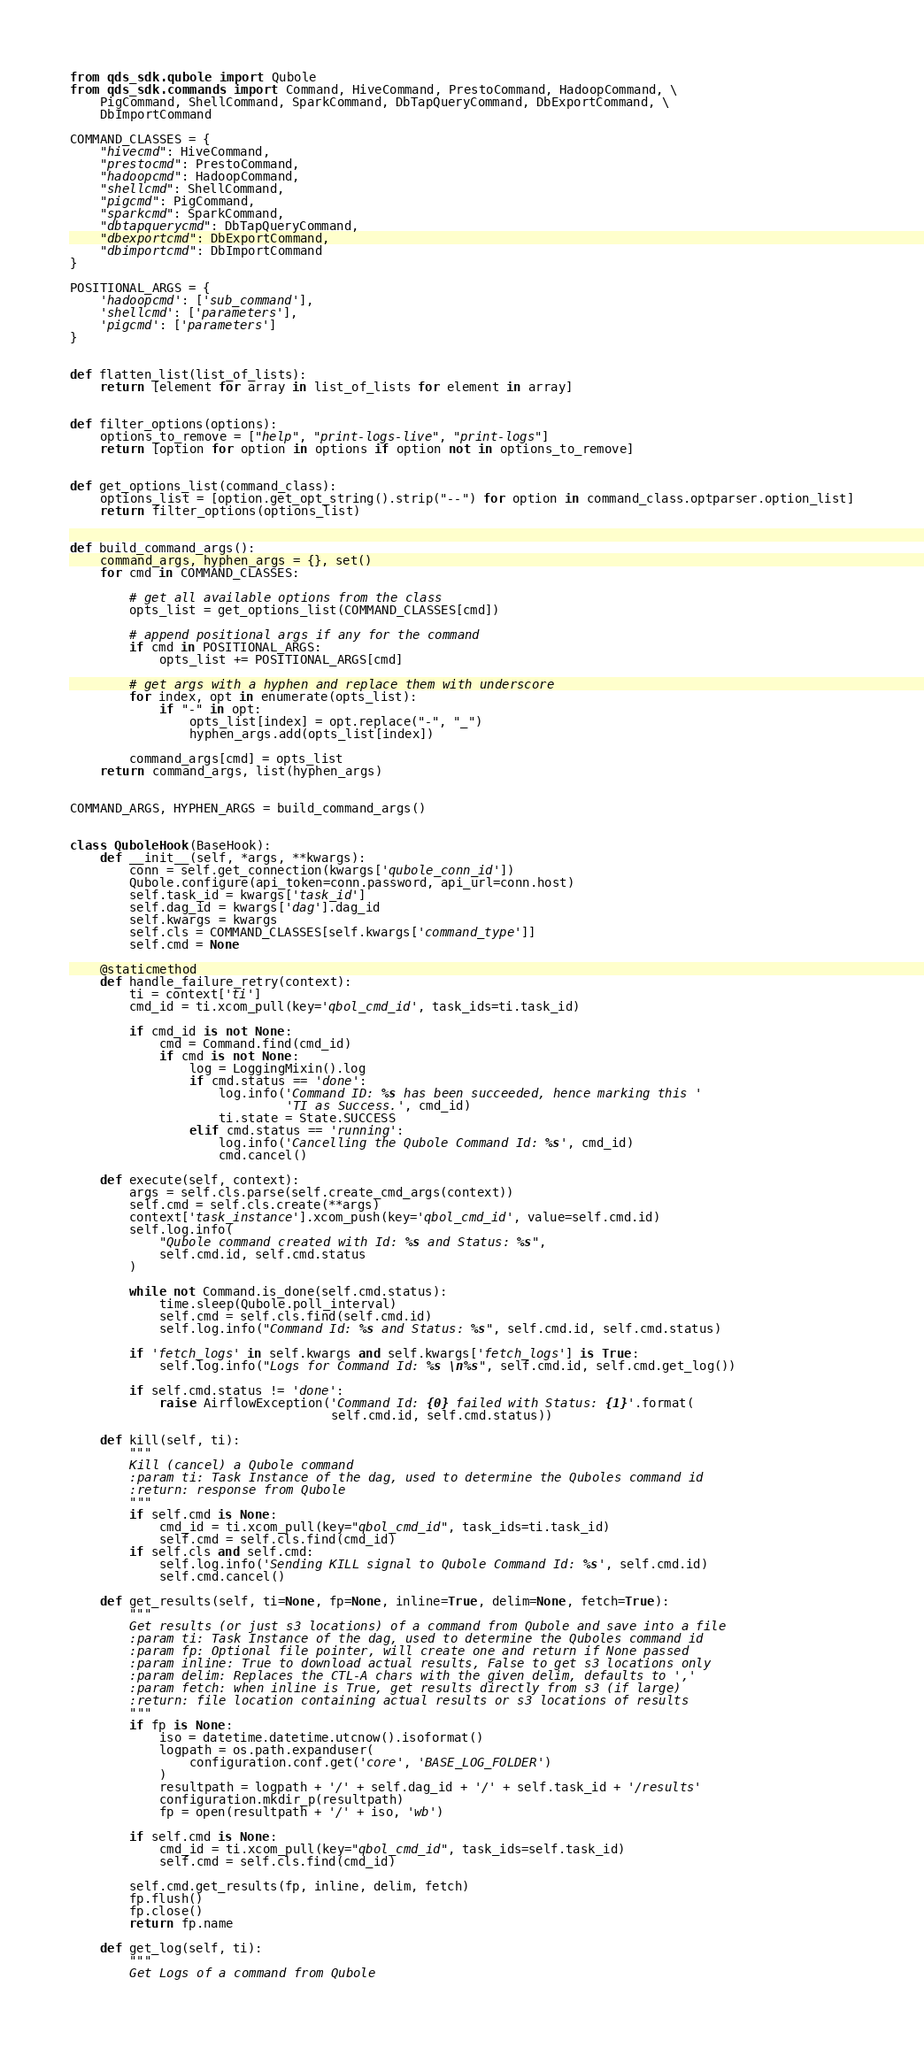Convert code to text. <code><loc_0><loc_0><loc_500><loc_500><_Python_>from qds_sdk.qubole import Qubole
from qds_sdk.commands import Command, HiveCommand, PrestoCommand, HadoopCommand, \
    PigCommand, ShellCommand, SparkCommand, DbTapQueryCommand, DbExportCommand, \
    DbImportCommand

COMMAND_CLASSES = {
    "hivecmd": HiveCommand,
    "prestocmd": PrestoCommand,
    "hadoopcmd": HadoopCommand,
    "shellcmd": ShellCommand,
    "pigcmd": PigCommand,
    "sparkcmd": SparkCommand,
    "dbtapquerycmd": DbTapQueryCommand,
    "dbexportcmd": DbExportCommand,
    "dbimportcmd": DbImportCommand
}

POSITIONAL_ARGS = {
    'hadoopcmd': ['sub_command'],
    'shellcmd': ['parameters'],
    'pigcmd': ['parameters']
}


def flatten_list(list_of_lists):
    return [element for array in list_of_lists for element in array]


def filter_options(options):
    options_to_remove = ["help", "print-logs-live", "print-logs"]
    return [option for option in options if option not in options_to_remove]


def get_options_list(command_class):
    options_list = [option.get_opt_string().strip("--") for option in command_class.optparser.option_list]
    return filter_options(options_list)


def build_command_args():
    command_args, hyphen_args = {}, set()
    for cmd in COMMAND_CLASSES:

        # get all available options from the class
        opts_list = get_options_list(COMMAND_CLASSES[cmd])

        # append positional args if any for the command
        if cmd in POSITIONAL_ARGS:
            opts_list += POSITIONAL_ARGS[cmd]

        # get args with a hyphen and replace them with underscore
        for index, opt in enumerate(opts_list):
            if "-" in opt:
                opts_list[index] = opt.replace("-", "_")
                hyphen_args.add(opts_list[index])

        command_args[cmd] = opts_list
    return command_args, list(hyphen_args)


COMMAND_ARGS, HYPHEN_ARGS = build_command_args()


class QuboleHook(BaseHook):
    def __init__(self, *args, **kwargs):
        conn = self.get_connection(kwargs['qubole_conn_id'])
        Qubole.configure(api_token=conn.password, api_url=conn.host)
        self.task_id = kwargs['task_id']
        self.dag_id = kwargs['dag'].dag_id
        self.kwargs = kwargs
        self.cls = COMMAND_CLASSES[self.kwargs['command_type']]
        self.cmd = None

    @staticmethod
    def handle_failure_retry(context):
        ti = context['ti']
        cmd_id = ti.xcom_pull(key='qbol_cmd_id', task_ids=ti.task_id)

        if cmd_id is not None:
            cmd = Command.find(cmd_id)
            if cmd is not None:
                log = LoggingMixin().log
                if cmd.status == 'done':
                    log.info('Command ID: %s has been succeeded, hence marking this '
                             'TI as Success.', cmd_id)
                    ti.state = State.SUCCESS
                elif cmd.status == 'running':
                    log.info('Cancelling the Qubole Command Id: %s', cmd_id)
                    cmd.cancel()

    def execute(self, context):
        args = self.cls.parse(self.create_cmd_args(context))
        self.cmd = self.cls.create(**args)
        context['task_instance'].xcom_push(key='qbol_cmd_id', value=self.cmd.id)
        self.log.info(
            "Qubole command created with Id: %s and Status: %s",
            self.cmd.id, self.cmd.status
        )

        while not Command.is_done(self.cmd.status):
            time.sleep(Qubole.poll_interval)
            self.cmd = self.cls.find(self.cmd.id)
            self.log.info("Command Id: %s and Status: %s", self.cmd.id, self.cmd.status)

        if 'fetch_logs' in self.kwargs and self.kwargs['fetch_logs'] is True:
            self.log.info("Logs for Command Id: %s \n%s", self.cmd.id, self.cmd.get_log())

        if self.cmd.status != 'done':
            raise AirflowException('Command Id: {0} failed with Status: {1}'.format(
                                   self.cmd.id, self.cmd.status))

    def kill(self, ti):
        """
        Kill (cancel) a Qubole command
        :param ti: Task Instance of the dag, used to determine the Quboles command id
        :return: response from Qubole
        """
        if self.cmd is None:
            cmd_id = ti.xcom_pull(key="qbol_cmd_id", task_ids=ti.task_id)
            self.cmd = self.cls.find(cmd_id)
        if self.cls and self.cmd:
            self.log.info('Sending KILL signal to Qubole Command Id: %s', self.cmd.id)
            self.cmd.cancel()

    def get_results(self, ti=None, fp=None, inline=True, delim=None, fetch=True):
        """
        Get results (or just s3 locations) of a command from Qubole and save into a file
        :param ti: Task Instance of the dag, used to determine the Quboles command id
        :param fp: Optional file pointer, will create one and return if None passed
        :param inline: True to download actual results, False to get s3 locations only
        :param delim: Replaces the CTL-A chars with the given delim, defaults to ','
        :param fetch: when inline is True, get results directly from s3 (if large)
        :return: file location containing actual results or s3 locations of results
        """
        if fp is None:
            iso = datetime.datetime.utcnow().isoformat()
            logpath = os.path.expanduser(
                configuration.conf.get('core', 'BASE_LOG_FOLDER')
            )
            resultpath = logpath + '/' + self.dag_id + '/' + self.task_id + '/results'
            configuration.mkdir_p(resultpath)
            fp = open(resultpath + '/' + iso, 'wb')

        if self.cmd is None:
            cmd_id = ti.xcom_pull(key="qbol_cmd_id", task_ids=self.task_id)
            self.cmd = self.cls.find(cmd_id)

        self.cmd.get_results(fp, inline, delim, fetch)
        fp.flush()
        fp.close()
        return fp.name

    def get_log(self, ti):
        """
        Get Logs of a command from Qubole</code> 